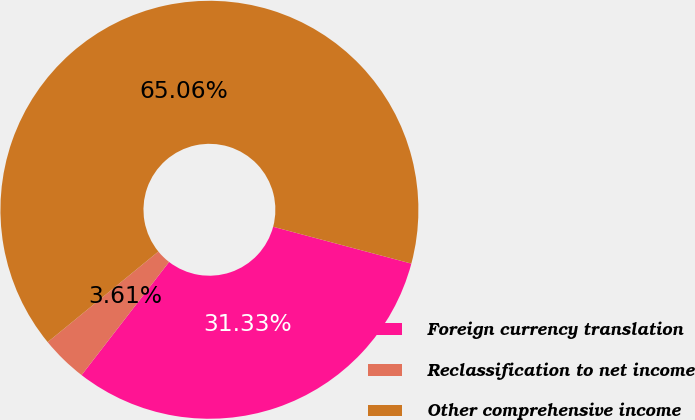Convert chart to OTSL. <chart><loc_0><loc_0><loc_500><loc_500><pie_chart><fcel>Foreign currency translation<fcel>Reclassification to net income<fcel>Other comprehensive income<nl><fcel>31.33%<fcel>3.61%<fcel>65.06%<nl></chart> 